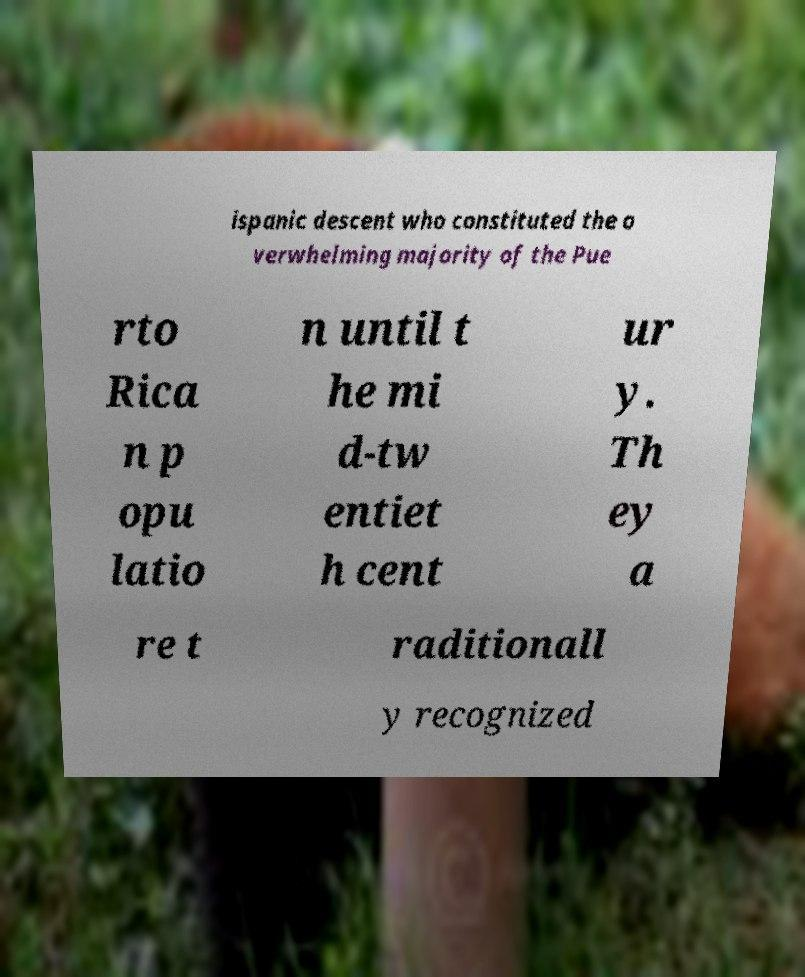Can you accurately transcribe the text from the provided image for me? ispanic descent who constituted the o verwhelming majority of the Pue rto Rica n p opu latio n until t he mi d-tw entiet h cent ur y. Th ey a re t raditionall y recognized 